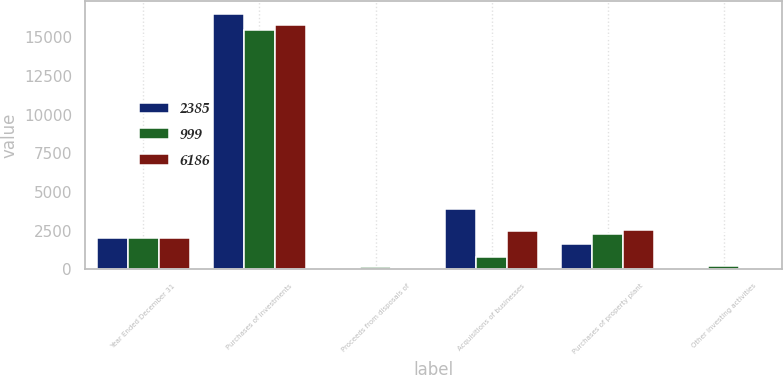Convert chart to OTSL. <chart><loc_0><loc_0><loc_500><loc_500><stacked_bar_chart><ecel><fcel>Year Ended December 31<fcel>Purchases of investments<fcel>Proceeds from disposals of<fcel>Acquisitions of businesses<fcel>Purchases of property plant<fcel>Other investing activities<nl><fcel>2385<fcel>2017<fcel>16520<fcel>104<fcel>3900<fcel>1675<fcel>126<nl><fcel>999<fcel>2016<fcel>15499<fcel>150<fcel>838<fcel>2262<fcel>209<nl><fcel>6186<fcel>2015<fcel>15831<fcel>85<fcel>2491<fcel>2553<fcel>40<nl></chart> 